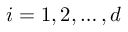Convert formula to latex. <formula><loc_0><loc_0><loc_500><loc_500>i = 1 , 2 , \dots , d</formula> 